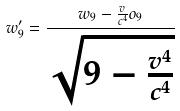Convert formula to latex. <formula><loc_0><loc_0><loc_500><loc_500>w _ { 9 } ^ { \prime } = \frac { w _ { 9 } - \frac { v } { c ^ { 4 } } o _ { 9 } } { \sqrt { 9 - \frac { v ^ { 4 } } { c ^ { 4 } } } }</formula> 